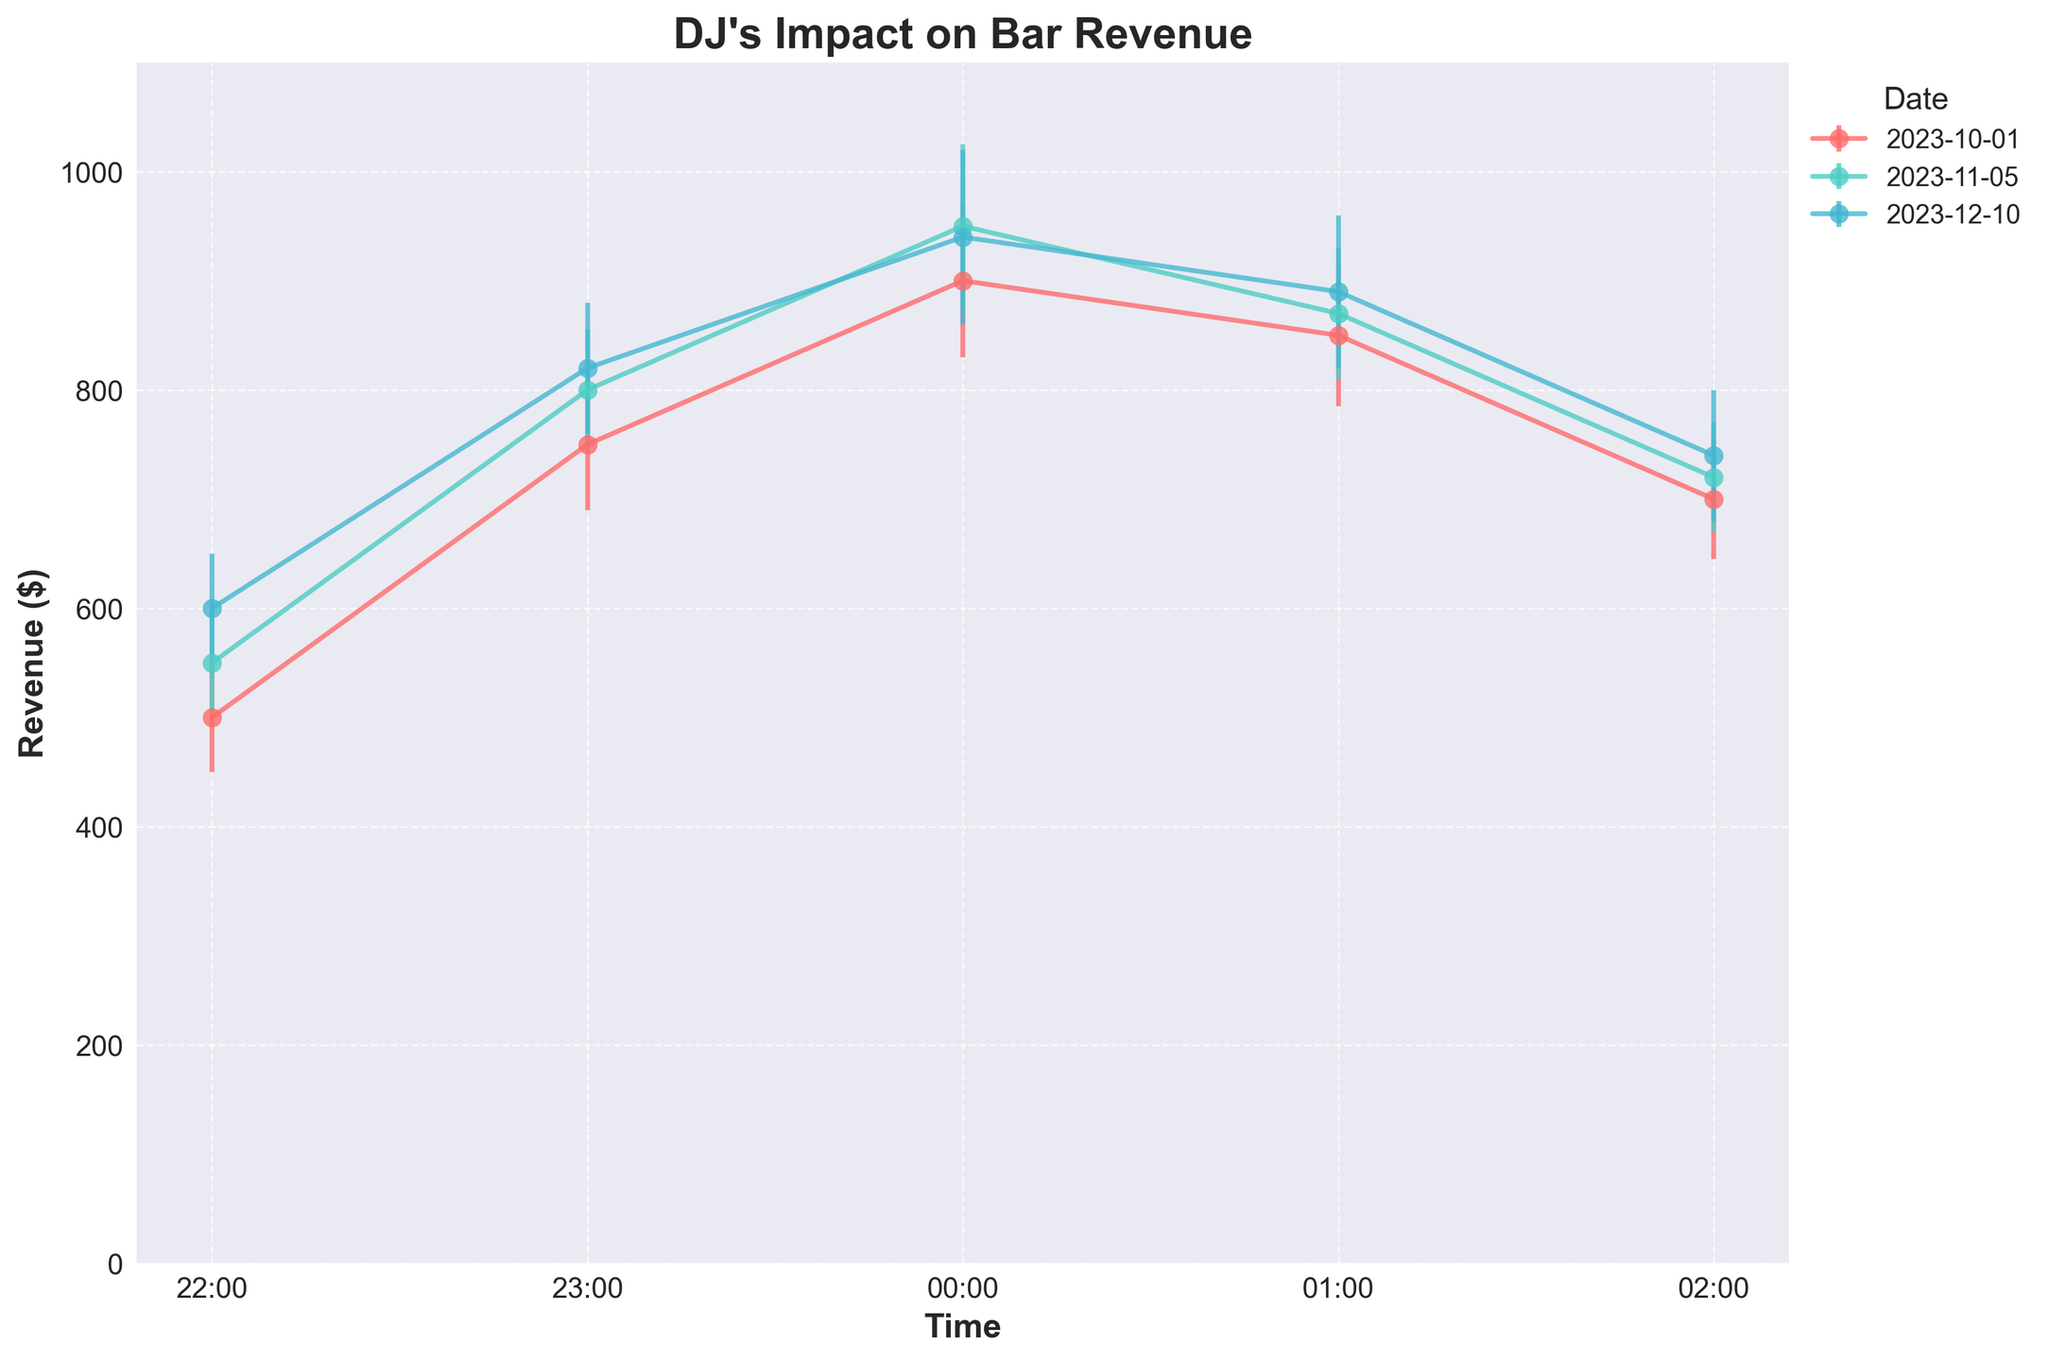What's the title of the plot? The title of the plot is typically located at the top center of the figure and is usually bold and larger in font size to indicate its importance. In this case, the title reads "DJ's Impact on Bar Revenue".
Answer: DJ's Impact on Bar Revenue Which time slot has the highest revenue on November 5, 2023? To determine this, look for the time point with the highest y-value under the label for November 5, 2023. The peak revenue values are plotted and can be identified with their corresponding times. Based on the plot, the highest revenue on November 5, 2023, occurs at 00:00.
Answer: 00:00 What is the general trend in revenue from 22:00 to 02:00 across all dates? Observing the graph from 22:00 to 02:00 across the different dates, a common trend can be identified. Typically, the revenue increases from 22:00, peaks around midnight (00:00 to 01:00), and then starts to decrease towards 02:00.
Answer: Increases then decreases What's the average revenue at 01:00 across all dates? To get the average, sum the revenues at 01:00 for all dates and divide by the number of dates. The revenues at 01:00 are 850, 870, and 890 for the three dates respectively. Thus, the average is (850 + 870 + 890) / 3 = 870.
Answer: 870 Which date shows the maximum revenue recorded in the plot? To find this, identify the highest point on the y-axis and note the corresponding date. Here, the highest revenue is $950, recorded on November 5, 2023.
Answer: November 5, 2023 Compare the revenue trend between the earliest and latest time slots for each date. By comparing the revenue at 22:00 (the earliest) and 02:00 (the latest), we see that the revenue generally starts lower at 22:00, increases towards midnight and then drops again. Specifically, for October 1, it starts at 500 and ends at 700, for November 5, it starts at 550 and ends at 720, and for December 10, it starts at 600 and ends at 740.
Answer: Lower at 22:00, higher towards midnight, then decreases at 02:00 What's the difference in revenue between 00:00 and 02:00 on December 10, 2023? Subtract the revenue at 02:00 from the revenue at 00:00 for December 10, 2023. The values are 740 at 02:00 and 940 at 00:00. Thus, the difference is 940 - 740 = 200.
Answer: 200 Which date had the most consistent revenue trend, considering the standard error bars? To assess consistency, evaluate the length of the error bars; shorter bars indicate less variability. By observing the plot, December 10, 2023, shows relatively short and consistent error bars, indicating a steadier revenue trend.
Answer: December 10, 2023 